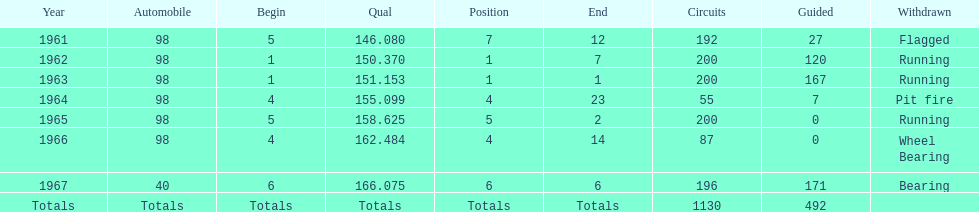What is the dissimilarity between the qualifying time in 1967 and 1965? 7.45. 